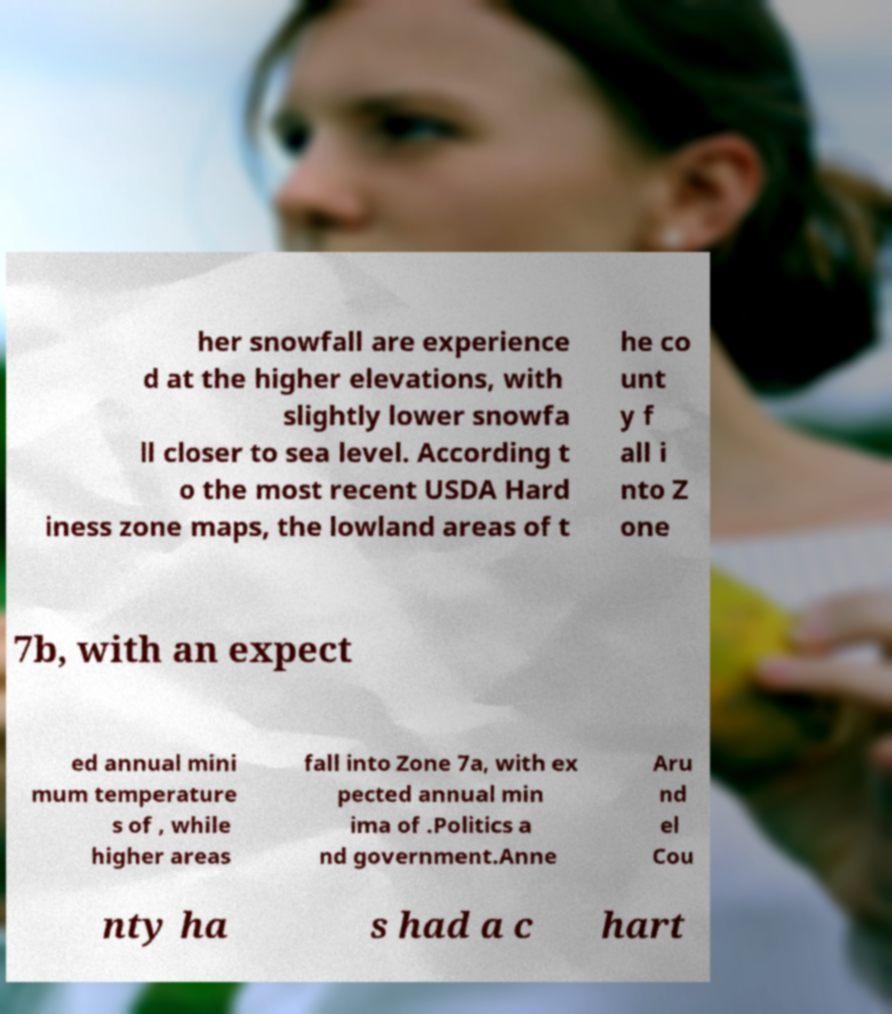Please read and relay the text visible in this image. What does it say? her snowfall are experience d at the higher elevations, with slightly lower snowfa ll closer to sea level. According t o the most recent USDA Hard iness zone maps, the lowland areas of t he co unt y f all i nto Z one 7b, with an expect ed annual mini mum temperature s of , while higher areas fall into Zone 7a, with ex pected annual min ima of .Politics a nd government.Anne Aru nd el Cou nty ha s had a c hart 